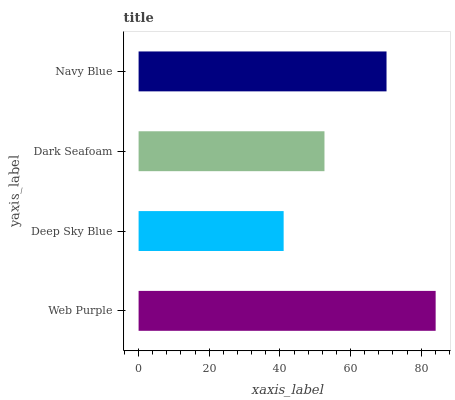Is Deep Sky Blue the minimum?
Answer yes or no. Yes. Is Web Purple the maximum?
Answer yes or no. Yes. Is Dark Seafoam the minimum?
Answer yes or no. No. Is Dark Seafoam the maximum?
Answer yes or no. No. Is Dark Seafoam greater than Deep Sky Blue?
Answer yes or no. Yes. Is Deep Sky Blue less than Dark Seafoam?
Answer yes or no. Yes. Is Deep Sky Blue greater than Dark Seafoam?
Answer yes or no. No. Is Dark Seafoam less than Deep Sky Blue?
Answer yes or no. No. Is Navy Blue the high median?
Answer yes or no. Yes. Is Dark Seafoam the low median?
Answer yes or no. Yes. Is Dark Seafoam the high median?
Answer yes or no. No. Is Navy Blue the low median?
Answer yes or no. No. 